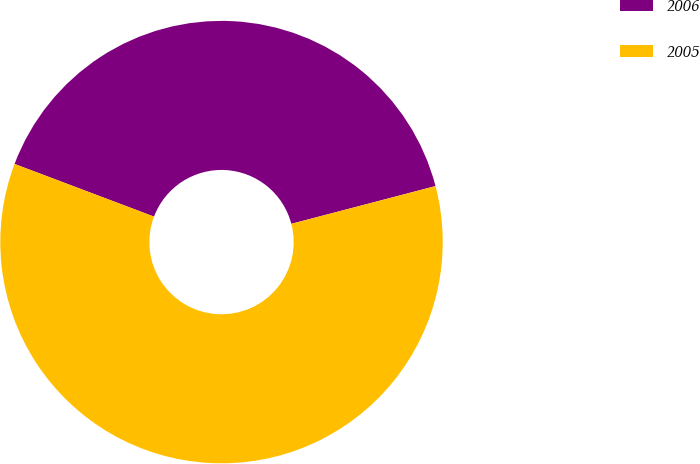Convert chart. <chart><loc_0><loc_0><loc_500><loc_500><pie_chart><fcel>2006<fcel>2005<nl><fcel>40.18%<fcel>59.82%<nl></chart> 